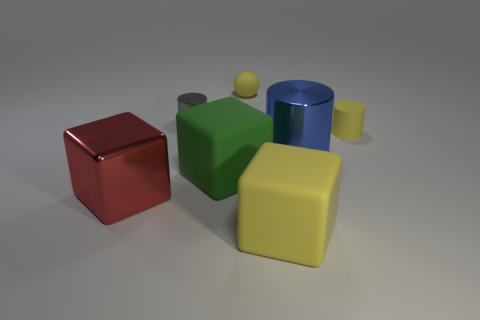How many other things are there of the same size as the blue cylinder?
Provide a succinct answer. 3. How many objects are to the right of the red shiny thing?
Give a very brief answer. 6. What is the size of the blue shiny thing?
Provide a succinct answer. Large. Is the tiny cylinder on the left side of the big blue object made of the same material as the small cylinder that is to the right of the green block?
Offer a very short reply. No. Is there a ball of the same color as the tiny metallic thing?
Your response must be concise. No. There is another cylinder that is the same size as the matte cylinder; what is its color?
Provide a succinct answer. Gray. Do the large object in front of the big red shiny block and the matte ball have the same color?
Provide a short and direct response. Yes. Is there a big object that has the same material as the yellow cylinder?
Your response must be concise. Yes. What is the shape of the large rubber object that is the same color as the ball?
Offer a very short reply. Cube. Are there fewer yellow rubber cylinders that are behind the rubber ball than big red rubber objects?
Keep it short and to the point. No. 